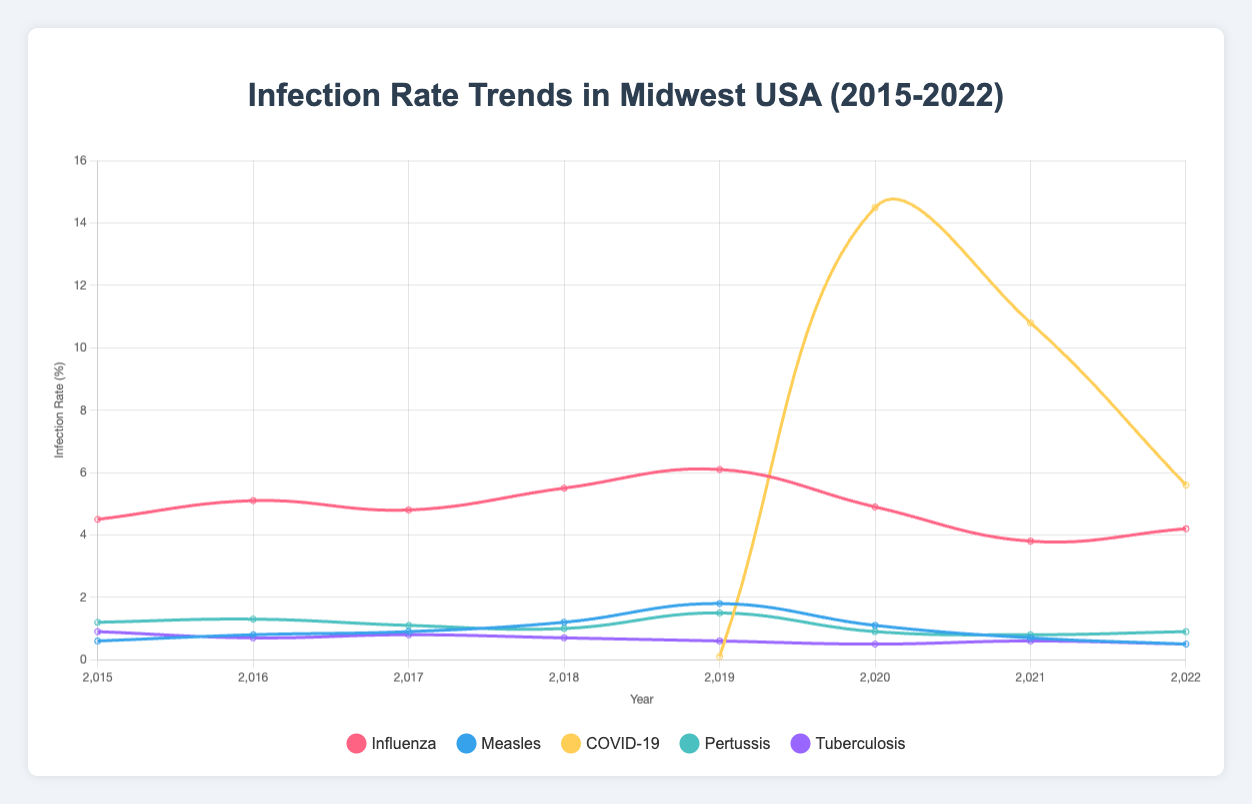What year saw the highest infection rate for Influenza? The highest infection rate for Influenza is observed by checking the plot for the peak value on the Influenza curve across all years. The highest point on the curve is in 2019.
Answer: 2019 In which year did Measles have its peak infection rate, and how does it compare to the peak infection rate of Influenza in that same year? The peak infection rate for Measles is in 2019 and is observed to be 1.8%. In the same year, the peak infection rate for Influenza is 6.1%. Comparing these two values, Measles had a lower peak infection rate than Influenza in 2019.
Answer: 2019, Measles (1.8%) is lower than Influenza (6.1%) What is the average infection rate for Pertussis from 2015 to 2022? To find the average infection rate for Pertussis, sum the rates from each year and divide by the number of years: (1.2 + 1.3 + 1.1 + 1.0 + 1.5 + 0.9 + 0.8 + 0.9) / 8 = 8.7 / 8 = 1.0875.
Answer: 1.0875 Which disease had the lowest infection rate in 2020? In 2020, the infection rates for each disease are checked: Influenza (4.9), Measles (1.1), COVID-19 (14.5), Pertussis (0.9), Tuberculosis (0.5). The lowest rate is for Tuberculosis at 0.5%.
Answer: Tuberculosis Between 2019 and 2022, which disease shows the most significant decrease in infection rate, and by how much? Calculate the differences from 2019 to 2022 for each disease: Influenza (6.1 - 4.2 = 1.9), Measles (1.8 - 0.5 = 1.3), COVID-19 (14.5 - 5.6 = 8.9), Pertussis (1.5 - 0.9 = 0.6), Tuberculosis (0.6 - 0.5 = 0.1). The most significant reduction is in COVID-19, which decreased by 8.9 percentage points.
Answer: COVID-19, 8.9 How did the infection rates of Tuberculosis and Pertussis compare visually in 2021? In 2021, Tuberculosis has a stable rate of 0.6%, and Pertussis has a rate of 0.8%. Visually, the curve for Pertussis is slightly above the curve for Tuberculosis for that year.
Answer: Pertussis is higher than Tuberculosis What is the difference in the infection rates of COVID-19 between its peak year and its lowest year? The peak infection rate for COVID-19 is in 2020 with 14.5%, and the lowest in 2019 with 0.1%. The difference is calculated as 14.5 - 0.1 = 14.4%.
Answer: 14.4 Which disease had the most stable infection rate between 2015 and 2022? To determine stability, we assess fluctuations in the infection rates for each disease over the years. Tuberculosis shows minimal fluctuation with rates around 0.5-0.9, suggesting it is the most stable.
Answer: Tuberculosis For which years is the infection rate for Influenza above 5%? Observing the plot, Influenza's infection rate exceeds 5% in 2016 (5.1%), 2018 (5.5%), and 2019 (6.1%).
Answer: 2016, 2018, 2019 How much higher was the infection rate of COVID-19 in 2020 compared to the infection rate of Influenza in the same year? COVID-19 had an infection rate of 14.5% in 2020, whereas Influenza had 4.9%. The difference is 14.5 - 4.9 = 9.6%.
Answer: 9.6 